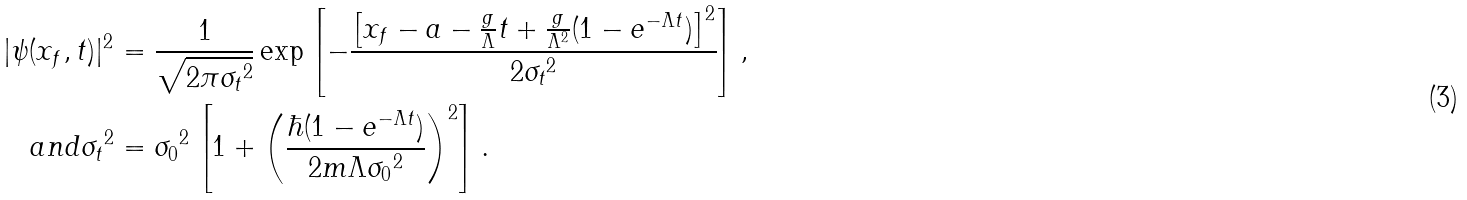Convert formula to latex. <formula><loc_0><loc_0><loc_500><loc_500>| \psi ( x _ { f } , t ) | ^ { 2 } & = \frac { 1 } { \sqrt { 2 \pi { \sigma _ { t } } ^ { 2 } } } \exp \left [ - \frac { \left [ x _ { f } - a - \frac { g } { \Lambda } t + \frac { g } { \Lambda ^ { 2 } } ( 1 - e ^ { - \Lambda t } ) \right ] ^ { 2 } } { 2 { \sigma _ { t } } ^ { 2 } } \right ] , \\ { a n d } { \sigma _ { t } } ^ { 2 } & = { \sigma _ { 0 } } ^ { 2 } \left [ 1 + \left ( \frac { \hbar { ( } 1 - e ^ { - \Lambda t } ) } { 2 m \Lambda { \sigma _ { 0 } } ^ { 2 } } \right ) ^ { 2 } \right ] .</formula> 